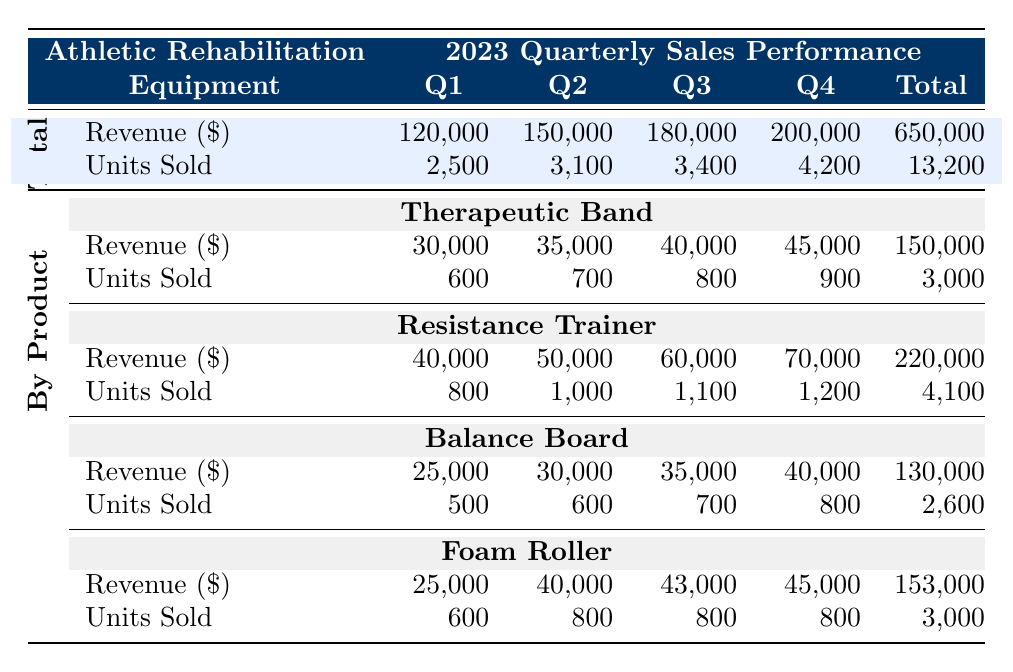What was the total revenue from sales in Q3? From the table, the total revenue in Q3 is listed directly as 180,000.
Answer: 180,000 How many units of the Resistance Trainer were sold in Q4? The table indicates that 1,200 units of the Resistance Trainer were sold in Q4.
Answer: 1,200 What is the combined total revenue of all equipment in Q1? The total revenue for all equipment in Q1 is the sum of the revenues: 30,000 (Therapeutic Band) + 40,000 (Resistance Trainer) + 25,000 (Balance Board) + 25,000 (Foam Roller) = 120,000, confirming the total listed for Q1.
Answer: 120,000 Did the revenue from the Balance Board increase every quarter? The revenues for the Balance Board in quarters are: 25,000 (Q1), 30,000 (Q2), 35,000 (Q3), and 40,000 (Q4). Since each value is higher than the previous, this is true.
Answer: Yes What was the unit sales change from Q2 to Q3 for the Foam Roller? Foam Roller unit sales in Q2 were 800 and in Q3 were also 800. The change is calculated as 800 - 800 = 0, indicating no change in units sold between the two quarters.
Answer: 0 Which quarter had the highest total units sold for all equipment? The total units sold were: 2,500 (Q1), 3,100 (Q2), 3,400 (Q3), and 4,200 (Q4). The highest is 4,200 in Q4.
Answer: Q4 Calculate the average units sold per quarter for the Therapeutic Band. Total units sold for the Therapeutic Band are 600 (Q1) + 700 (Q2) + 800 (Q3) + 900 (Q4) = 3,000. Average is 3,000 / 4 = 750.
Answer: 750 In which quarter did the Resistance Trainer generate the most revenue? The revenues for the Resistance Trainer by quarter are: 40,000 (Q1), 50,000 (Q2), 60,000 (Q3), and 70,000 (Q4). The highest is in Q4 with 70,000.
Answer: Q4 How much revenue did the Foam Roller generate in total for the year? The Foam Roller revenues by quarter are: 25,000 (Q1) + 40,000 (Q2) + 43,000 (Q3) + 45,000 (Q4) = 153,000.
Answer: 153,000 